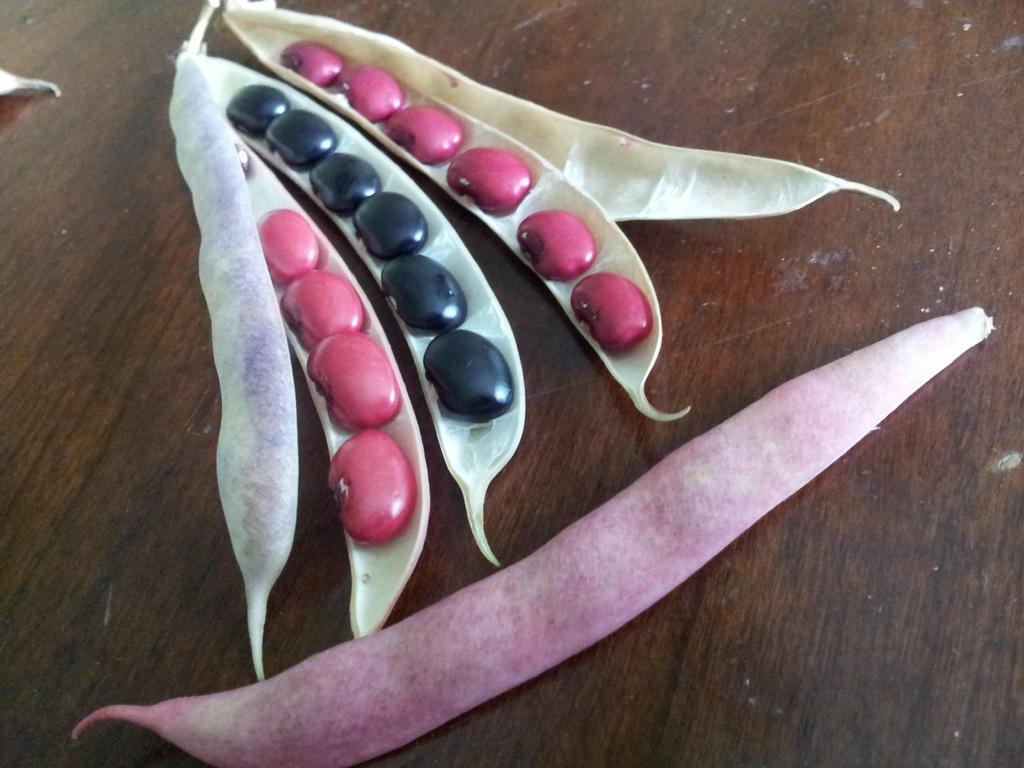Can you describe this image briefly? In this picture we can see peas. 